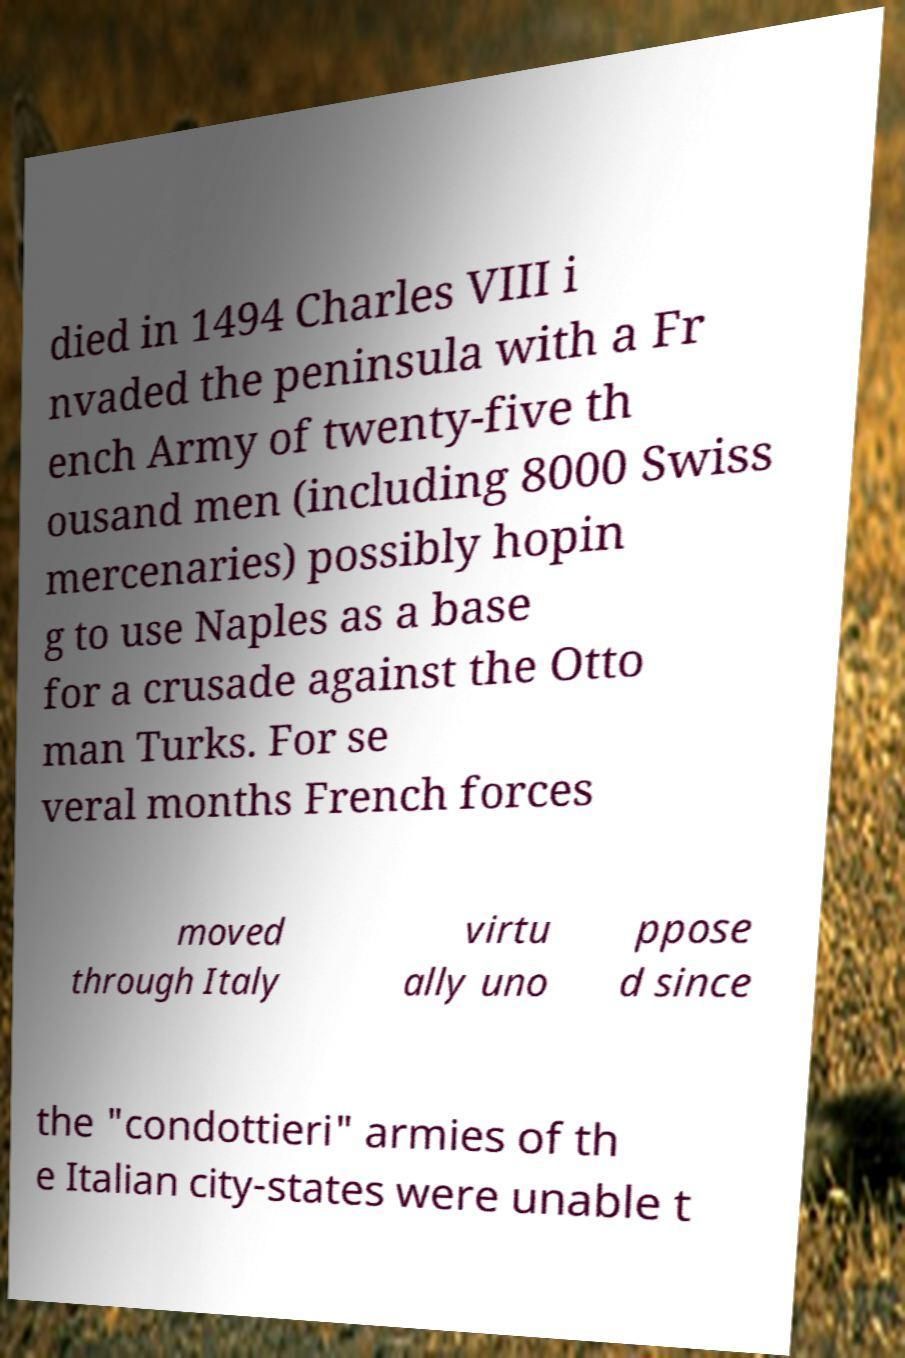Can you accurately transcribe the text from the provided image for me? died in 1494 Charles VIII i nvaded the peninsula with a Fr ench Army of twenty-five th ousand men (including 8000 Swiss mercenaries) possibly hopin g to use Naples as a base for a crusade against the Otto man Turks. For se veral months French forces moved through Italy virtu ally uno ppose d since the "condottieri" armies of th e Italian city-states were unable t 